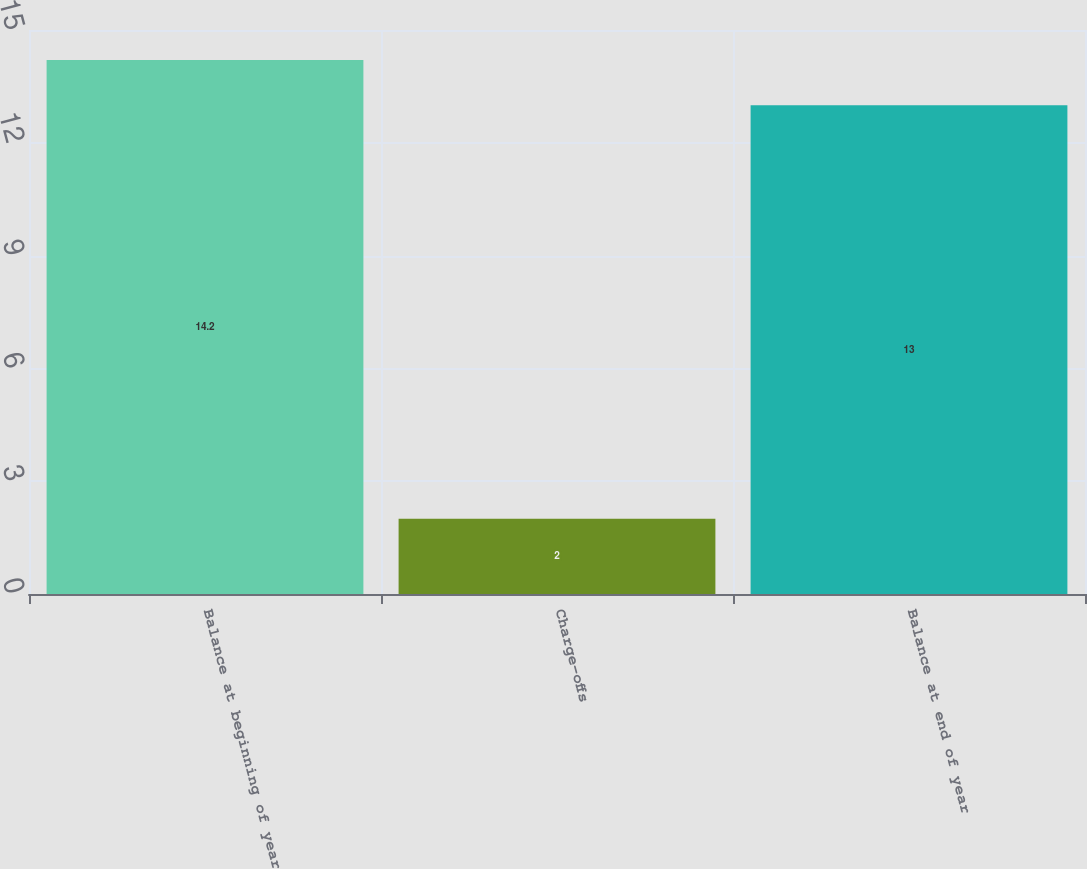Convert chart to OTSL. <chart><loc_0><loc_0><loc_500><loc_500><bar_chart><fcel>Balance at beginning of year<fcel>Charge-offs<fcel>Balance at end of year<nl><fcel>14.2<fcel>2<fcel>13<nl></chart> 